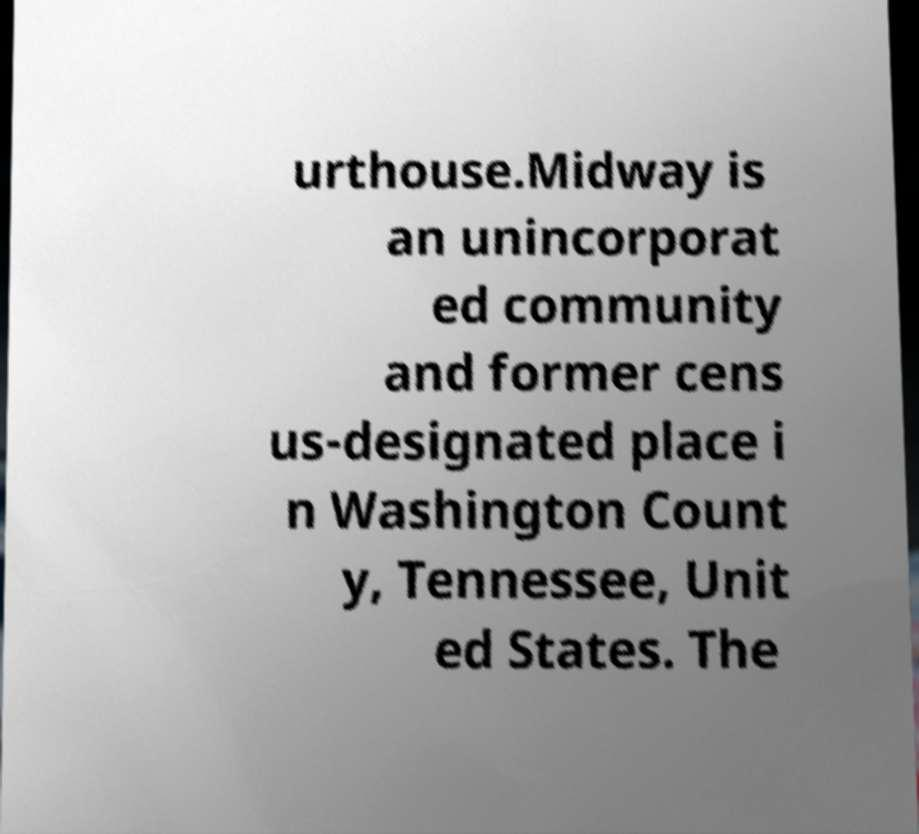I need the written content from this picture converted into text. Can you do that? urthouse.Midway is an unincorporat ed community and former cens us-designated place i n Washington Count y, Tennessee, Unit ed States. The 